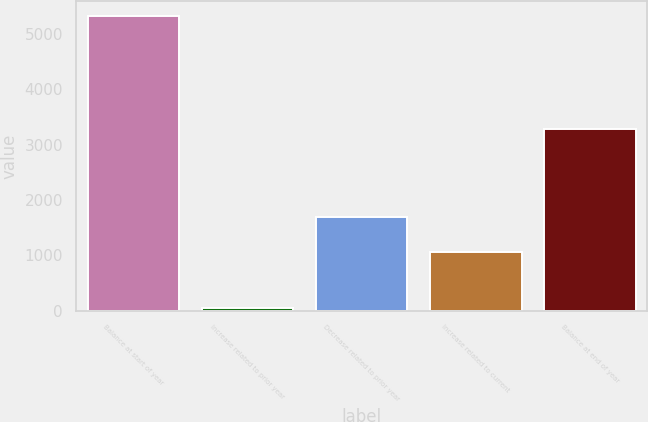Convert chart to OTSL. <chart><loc_0><loc_0><loc_500><loc_500><bar_chart><fcel>Balance at start of year<fcel>Increase related to prior year<fcel>Decrease related to prior year<fcel>Increase related to current<fcel>Balance at end of year<nl><fcel>5331<fcel>37<fcel>1695<fcel>1058<fcel>3282<nl></chart> 